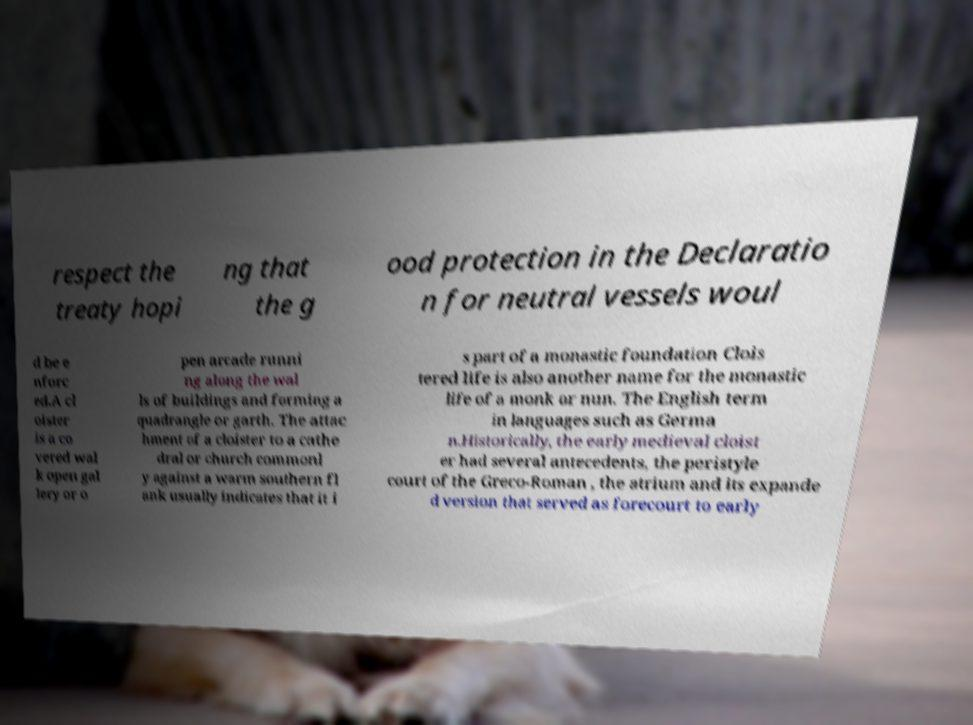Could you extract and type out the text from this image? respect the treaty hopi ng that the g ood protection in the Declaratio n for neutral vessels woul d be e nforc ed.A cl oister is a co vered wal k open gal lery or o pen arcade runni ng along the wal ls of buildings and forming a quadrangle or garth. The attac hment of a cloister to a cathe dral or church commonl y against a warm southern fl ank usually indicates that it i s part of a monastic foundation Clois tered life is also another name for the monastic life of a monk or nun. The English term in languages such as Germa n.Historically, the early medieval cloist er had several antecedents, the peristyle court of the Greco-Roman , the atrium and its expande d version that served as forecourt to early 